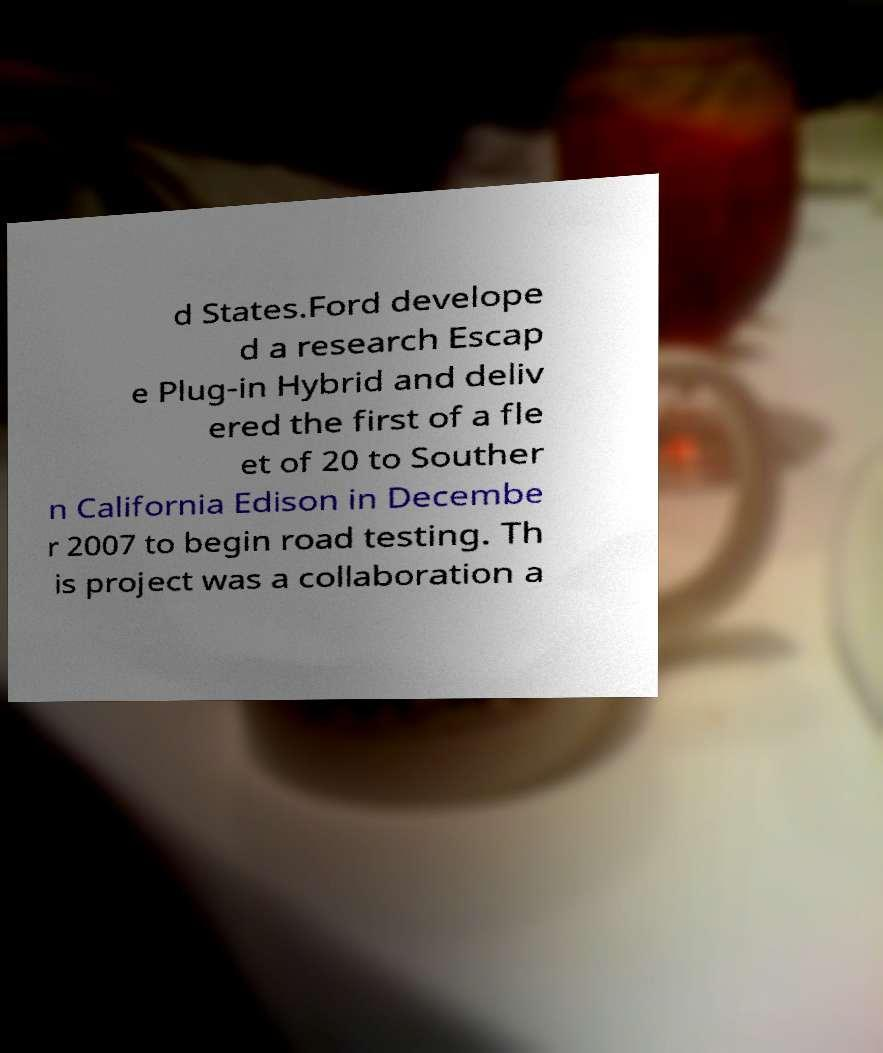Can you accurately transcribe the text from the provided image for me? d States.Ford develope d a research Escap e Plug-in Hybrid and deliv ered the first of a fle et of 20 to Souther n California Edison in Decembe r 2007 to begin road testing. Th is project was a collaboration a 